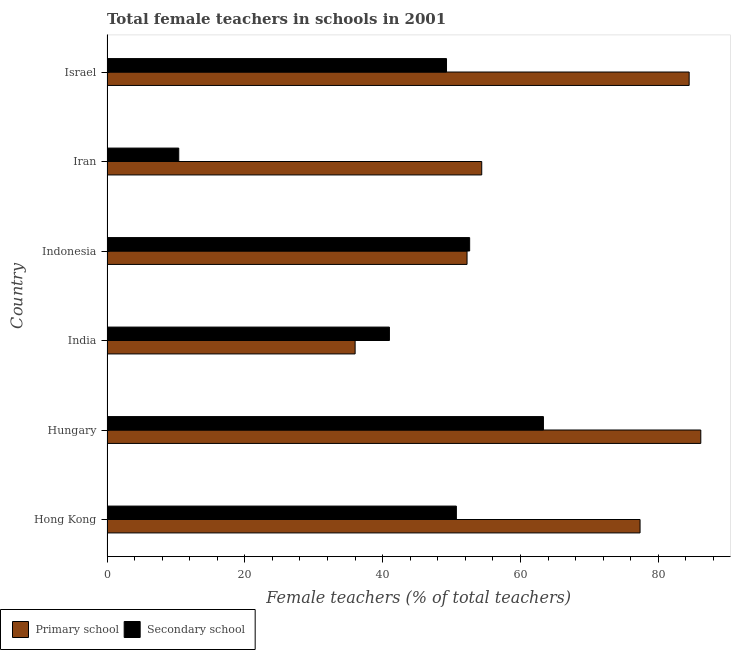How many different coloured bars are there?
Your response must be concise. 2. How many bars are there on the 1st tick from the bottom?
Provide a short and direct response. 2. What is the label of the 1st group of bars from the top?
Offer a terse response. Israel. In how many cases, is the number of bars for a given country not equal to the number of legend labels?
Make the answer very short. 0. What is the percentage of female teachers in primary schools in Hong Kong?
Keep it short and to the point. 77.34. Across all countries, what is the maximum percentage of female teachers in primary schools?
Provide a succinct answer. 86.15. Across all countries, what is the minimum percentage of female teachers in primary schools?
Ensure brevity in your answer.  36. In which country was the percentage of female teachers in primary schools maximum?
Make the answer very short. Hungary. In which country was the percentage of female teachers in secondary schools minimum?
Offer a very short reply. Iran. What is the total percentage of female teachers in secondary schools in the graph?
Offer a terse response. 267.27. What is the difference between the percentage of female teachers in primary schools in Hong Kong and that in Israel?
Provide a succinct answer. -7.12. What is the difference between the percentage of female teachers in primary schools in Hungary and the percentage of female teachers in secondary schools in Israel?
Provide a short and direct response. 36.89. What is the average percentage of female teachers in primary schools per country?
Offer a terse response. 65.09. What is the difference between the percentage of female teachers in secondary schools and percentage of female teachers in primary schools in Indonesia?
Make the answer very short. 0.38. What is the ratio of the percentage of female teachers in secondary schools in Indonesia to that in Israel?
Your response must be concise. 1.07. Is the percentage of female teachers in primary schools in Hungary less than that in India?
Offer a very short reply. No. What is the difference between the highest and the second highest percentage of female teachers in primary schools?
Offer a very short reply. 1.69. What is the difference between the highest and the lowest percentage of female teachers in secondary schools?
Offer a very short reply. 52.91. In how many countries, is the percentage of female teachers in secondary schools greater than the average percentage of female teachers in secondary schools taken over all countries?
Provide a short and direct response. 4. Is the sum of the percentage of female teachers in primary schools in Hungary and Israel greater than the maximum percentage of female teachers in secondary schools across all countries?
Give a very brief answer. Yes. What does the 2nd bar from the top in Iran represents?
Ensure brevity in your answer.  Primary school. What does the 1st bar from the bottom in Hong Kong represents?
Provide a succinct answer. Primary school. How many bars are there?
Give a very brief answer. 12. Are all the bars in the graph horizontal?
Your answer should be compact. Yes. Are the values on the major ticks of X-axis written in scientific E-notation?
Provide a succinct answer. No. Does the graph contain grids?
Your answer should be compact. No. Where does the legend appear in the graph?
Keep it short and to the point. Bottom left. What is the title of the graph?
Ensure brevity in your answer.  Total female teachers in schools in 2001. What is the label or title of the X-axis?
Ensure brevity in your answer.  Female teachers (% of total teachers). What is the label or title of the Y-axis?
Offer a terse response. Country. What is the Female teachers (% of total teachers) in Primary school in Hong Kong?
Provide a short and direct response. 77.34. What is the Female teachers (% of total teachers) of Secondary school in Hong Kong?
Give a very brief answer. 50.69. What is the Female teachers (% of total teachers) in Primary school in Hungary?
Offer a very short reply. 86.15. What is the Female teachers (% of total teachers) in Secondary school in Hungary?
Your answer should be very brief. 63.32. What is the Female teachers (% of total teachers) in Primary school in India?
Provide a succinct answer. 36. What is the Female teachers (% of total teachers) of Secondary school in India?
Make the answer very short. 40.98. What is the Female teachers (% of total teachers) of Primary school in Indonesia?
Your answer should be very brief. 52.24. What is the Female teachers (% of total teachers) of Secondary school in Indonesia?
Your answer should be very brief. 52.62. What is the Female teachers (% of total teachers) in Primary school in Iran?
Offer a terse response. 54.37. What is the Female teachers (% of total teachers) of Secondary school in Iran?
Ensure brevity in your answer.  10.41. What is the Female teachers (% of total teachers) in Primary school in Israel?
Provide a short and direct response. 84.47. What is the Female teachers (% of total teachers) in Secondary school in Israel?
Your response must be concise. 49.26. Across all countries, what is the maximum Female teachers (% of total teachers) in Primary school?
Your answer should be very brief. 86.15. Across all countries, what is the maximum Female teachers (% of total teachers) in Secondary school?
Your response must be concise. 63.32. Across all countries, what is the minimum Female teachers (% of total teachers) of Primary school?
Offer a terse response. 36. Across all countries, what is the minimum Female teachers (% of total teachers) of Secondary school?
Provide a succinct answer. 10.41. What is the total Female teachers (% of total teachers) of Primary school in the graph?
Provide a succinct answer. 390.57. What is the total Female teachers (% of total teachers) of Secondary school in the graph?
Offer a terse response. 267.27. What is the difference between the Female teachers (% of total teachers) of Primary school in Hong Kong and that in Hungary?
Your answer should be very brief. -8.81. What is the difference between the Female teachers (% of total teachers) in Secondary school in Hong Kong and that in Hungary?
Provide a short and direct response. -12.63. What is the difference between the Female teachers (% of total teachers) of Primary school in Hong Kong and that in India?
Provide a short and direct response. 41.34. What is the difference between the Female teachers (% of total teachers) of Secondary school in Hong Kong and that in India?
Provide a succinct answer. 9.71. What is the difference between the Female teachers (% of total teachers) of Primary school in Hong Kong and that in Indonesia?
Give a very brief answer. 25.1. What is the difference between the Female teachers (% of total teachers) of Secondary school in Hong Kong and that in Indonesia?
Offer a terse response. -1.93. What is the difference between the Female teachers (% of total teachers) of Primary school in Hong Kong and that in Iran?
Give a very brief answer. 22.97. What is the difference between the Female teachers (% of total teachers) of Secondary school in Hong Kong and that in Iran?
Keep it short and to the point. 40.28. What is the difference between the Female teachers (% of total teachers) in Primary school in Hong Kong and that in Israel?
Ensure brevity in your answer.  -7.12. What is the difference between the Female teachers (% of total teachers) in Secondary school in Hong Kong and that in Israel?
Provide a succinct answer. 1.43. What is the difference between the Female teachers (% of total teachers) of Primary school in Hungary and that in India?
Give a very brief answer. 50.15. What is the difference between the Female teachers (% of total teachers) in Secondary school in Hungary and that in India?
Offer a terse response. 22.34. What is the difference between the Female teachers (% of total teachers) of Primary school in Hungary and that in Indonesia?
Keep it short and to the point. 33.92. What is the difference between the Female teachers (% of total teachers) in Secondary school in Hungary and that in Indonesia?
Ensure brevity in your answer.  10.7. What is the difference between the Female teachers (% of total teachers) of Primary school in Hungary and that in Iran?
Provide a short and direct response. 31.78. What is the difference between the Female teachers (% of total teachers) of Secondary school in Hungary and that in Iran?
Provide a succinct answer. 52.91. What is the difference between the Female teachers (% of total teachers) of Primary school in Hungary and that in Israel?
Ensure brevity in your answer.  1.69. What is the difference between the Female teachers (% of total teachers) in Secondary school in Hungary and that in Israel?
Ensure brevity in your answer.  14.06. What is the difference between the Female teachers (% of total teachers) of Primary school in India and that in Indonesia?
Provide a short and direct response. -16.24. What is the difference between the Female teachers (% of total teachers) in Secondary school in India and that in Indonesia?
Your answer should be compact. -11.64. What is the difference between the Female teachers (% of total teachers) in Primary school in India and that in Iran?
Offer a terse response. -18.37. What is the difference between the Female teachers (% of total teachers) in Secondary school in India and that in Iran?
Ensure brevity in your answer.  30.57. What is the difference between the Female teachers (% of total teachers) in Primary school in India and that in Israel?
Provide a short and direct response. -48.47. What is the difference between the Female teachers (% of total teachers) of Secondary school in India and that in Israel?
Your response must be concise. -8.28. What is the difference between the Female teachers (% of total teachers) of Primary school in Indonesia and that in Iran?
Provide a short and direct response. -2.13. What is the difference between the Female teachers (% of total teachers) in Secondary school in Indonesia and that in Iran?
Make the answer very short. 42.21. What is the difference between the Female teachers (% of total teachers) of Primary school in Indonesia and that in Israel?
Offer a very short reply. -32.23. What is the difference between the Female teachers (% of total teachers) in Secondary school in Indonesia and that in Israel?
Keep it short and to the point. 3.36. What is the difference between the Female teachers (% of total teachers) in Primary school in Iran and that in Israel?
Your answer should be compact. -30.09. What is the difference between the Female teachers (% of total teachers) of Secondary school in Iran and that in Israel?
Ensure brevity in your answer.  -38.85. What is the difference between the Female teachers (% of total teachers) in Primary school in Hong Kong and the Female teachers (% of total teachers) in Secondary school in Hungary?
Ensure brevity in your answer.  14.02. What is the difference between the Female teachers (% of total teachers) of Primary school in Hong Kong and the Female teachers (% of total teachers) of Secondary school in India?
Provide a short and direct response. 36.36. What is the difference between the Female teachers (% of total teachers) of Primary school in Hong Kong and the Female teachers (% of total teachers) of Secondary school in Indonesia?
Your answer should be very brief. 24.72. What is the difference between the Female teachers (% of total teachers) of Primary school in Hong Kong and the Female teachers (% of total teachers) of Secondary school in Iran?
Keep it short and to the point. 66.93. What is the difference between the Female teachers (% of total teachers) in Primary school in Hong Kong and the Female teachers (% of total teachers) in Secondary school in Israel?
Make the answer very short. 28.08. What is the difference between the Female teachers (% of total teachers) in Primary school in Hungary and the Female teachers (% of total teachers) in Secondary school in India?
Keep it short and to the point. 45.18. What is the difference between the Female teachers (% of total teachers) in Primary school in Hungary and the Female teachers (% of total teachers) in Secondary school in Indonesia?
Provide a short and direct response. 33.54. What is the difference between the Female teachers (% of total teachers) of Primary school in Hungary and the Female teachers (% of total teachers) of Secondary school in Iran?
Make the answer very short. 75.75. What is the difference between the Female teachers (% of total teachers) in Primary school in Hungary and the Female teachers (% of total teachers) in Secondary school in Israel?
Offer a very short reply. 36.89. What is the difference between the Female teachers (% of total teachers) in Primary school in India and the Female teachers (% of total teachers) in Secondary school in Indonesia?
Give a very brief answer. -16.62. What is the difference between the Female teachers (% of total teachers) in Primary school in India and the Female teachers (% of total teachers) in Secondary school in Iran?
Offer a terse response. 25.59. What is the difference between the Female teachers (% of total teachers) in Primary school in India and the Female teachers (% of total teachers) in Secondary school in Israel?
Keep it short and to the point. -13.26. What is the difference between the Female teachers (% of total teachers) of Primary school in Indonesia and the Female teachers (% of total teachers) of Secondary school in Iran?
Offer a terse response. 41.83. What is the difference between the Female teachers (% of total teachers) of Primary school in Indonesia and the Female teachers (% of total teachers) of Secondary school in Israel?
Offer a terse response. 2.98. What is the difference between the Female teachers (% of total teachers) of Primary school in Iran and the Female teachers (% of total teachers) of Secondary school in Israel?
Offer a terse response. 5.11. What is the average Female teachers (% of total teachers) of Primary school per country?
Keep it short and to the point. 65.09. What is the average Female teachers (% of total teachers) of Secondary school per country?
Ensure brevity in your answer.  44.55. What is the difference between the Female teachers (% of total teachers) of Primary school and Female teachers (% of total teachers) of Secondary school in Hong Kong?
Make the answer very short. 26.65. What is the difference between the Female teachers (% of total teachers) of Primary school and Female teachers (% of total teachers) of Secondary school in Hungary?
Your response must be concise. 22.83. What is the difference between the Female teachers (% of total teachers) of Primary school and Female teachers (% of total teachers) of Secondary school in India?
Provide a short and direct response. -4.98. What is the difference between the Female teachers (% of total teachers) in Primary school and Female teachers (% of total teachers) in Secondary school in Indonesia?
Your response must be concise. -0.38. What is the difference between the Female teachers (% of total teachers) of Primary school and Female teachers (% of total teachers) of Secondary school in Iran?
Provide a short and direct response. 43.96. What is the difference between the Female teachers (% of total teachers) in Primary school and Female teachers (% of total teachers) in Secondary school in Israel?
Give a very brief answer. 35.21. What is the ratio of the Female teachers (% of total teachers) of Primary school in Hong Kong to that in Hungary?
Give a very brief answer. 0.9. What is the ratio of the Female teachers (% of total teachers) in Secondary school in Hong Kong to that in Hungary?
Ensure brevity in your answer.  0.8. What is the ratio of the Female teachers (% of total teachers) of Primary school in Hong Kong to that in India?
Make the answer very short. 2.15. What is the ratio of the Female teachers (% of total teachers) in Secondary school in Hong Kong to that in India?
Your answer should be very brief. 1.24. What is the ratio of the Female teachers (% of total teachers) in Primary school in Hong Kong to that in Indonesia?
Your answer should be very brief. 1.48. What is the ratio of the Female teachers (% of total teachers) in Secondary school in Hong Kong to that in Indonesia?
Provide a short and direct response. 0.96. What is the ratio of the Female teachers (% of total teachers) of Primary school in Hong Kong to that in Iran?
Make the answer very short. 1.42. What is the ratio of the Female teachers (% of total teachers) of Secondary school in Hong Kong to that in Iran?
Offer a terse response. 4.87. What is the ratio of the Female teachers (% of total teachers) in Primary school in Hong Kong to that in Israel?
Your response must be concise. 0.92. What is the ratio of the Female teachers (% of total teachers) of Primary school in Hungary to that in India?
Your response must be concise. 2.39. What is the ratio of the Female teachers (% of total teachers) of Secondary school in Hungary to that in India?
Provide a succinct answer. 1.55. What is the ratio of the Female teachers (% of total teachers) of Primary school in Hungary to that in Indonesia?
Provide a short and direct response. 1.65. What is the ratio of the Female teachers (% of total teachers) of Secondary school in Hungary to that in Indonesia?
Provide a succinct answer. 1.2. What is the ratio of the Female teachers (% of total teachers) in Primary school in Hungary to that in Iran?
Your answer should be compact. 1.58. What is the ratio of the Female teachers (% of total teachers) of Secondary school in Hungary to that in Iran?
Offer a very short reply. 6.08. What is the ratio of the Female teachers (% of total teachers) in Primary school in Hungary to that in Israel?
Give a very brief answer. 1.02. What is the ratio of the Female teachers (% of total teachers) of Secondary school in Hungary to that in Israel?
Offer a very short reply. 1.29. What is the ratio of the Female teachers (% of total teachers) of Primary school in India to that in Indonesia?
Give a very brief answer. 0.69. What is the ratio of the Female teachers (% of total teachers) in Secondary school in India to that in Indonesia?
Offer a very short reply. 0.78. What is the ratio of the Female teachers (% of total teachers) in Primary school in India to that in Iran?
Keep it short and to the point. 0.66. What is the ratio of the Female teachers (% of total teachers) of Secondary school in India to that in Iran?
Your answer should be compact. 3.94. What is the ratio of the Female teachers (% of total teachers) in Primary school in India to that in Israel?
Make the answer very short. 0.43. What is the ratio of the Female teachers (% of total teachers) in Secondary school in India to that in Israel?
Your answer should be very brief. 0.83. What is the ratio of the Female teachers (% of total teachers) in Primary school in Indonesia to that in Iran?
Your answer should be compact. 0.96. What is the ratio of the Female teachers (% of total teachers) of Secondary school in Indonesia to that in Iran?
Ensure brevity in your answer.  5.06. What is the ratio of the Female teachers (% of total teachers) of Primary school in Indonesia to that in Israel?
Make the answer very short. 0.62. What is the ratio of the Female teachers (% of total teachers) of Secondary school in Indonesia to that in Israel?
Provide a short and direct response. 1.07. What is the ratio of the Female teachers (% of total teachers) in Primary school in Iran to that in Israel?
Your response must be concise. 0.64. What is the ratio of the Female teachers (% of total teachers) of Secondary school in Iran to that in Israel?
Provide a short and direct response. 0.21. What is the difference between the highest and the second highest Female teachers (% of total teachers) in Primary school?
Offer a very short reply. 1.69. What is the difference between the highest and the second highest Female teachers (% of total teachers) in Secondary school?
Offer a terse response. 10.7. What is the difference between the highest and the lowest Female teachers (% of total teachers) of Primary school?
Your answer should be compact. 50.15. What is the difference between the highest and the lowest Female teachers (% of total teachers) in Secondary school?
Provide a short and direct response. 52.91. 